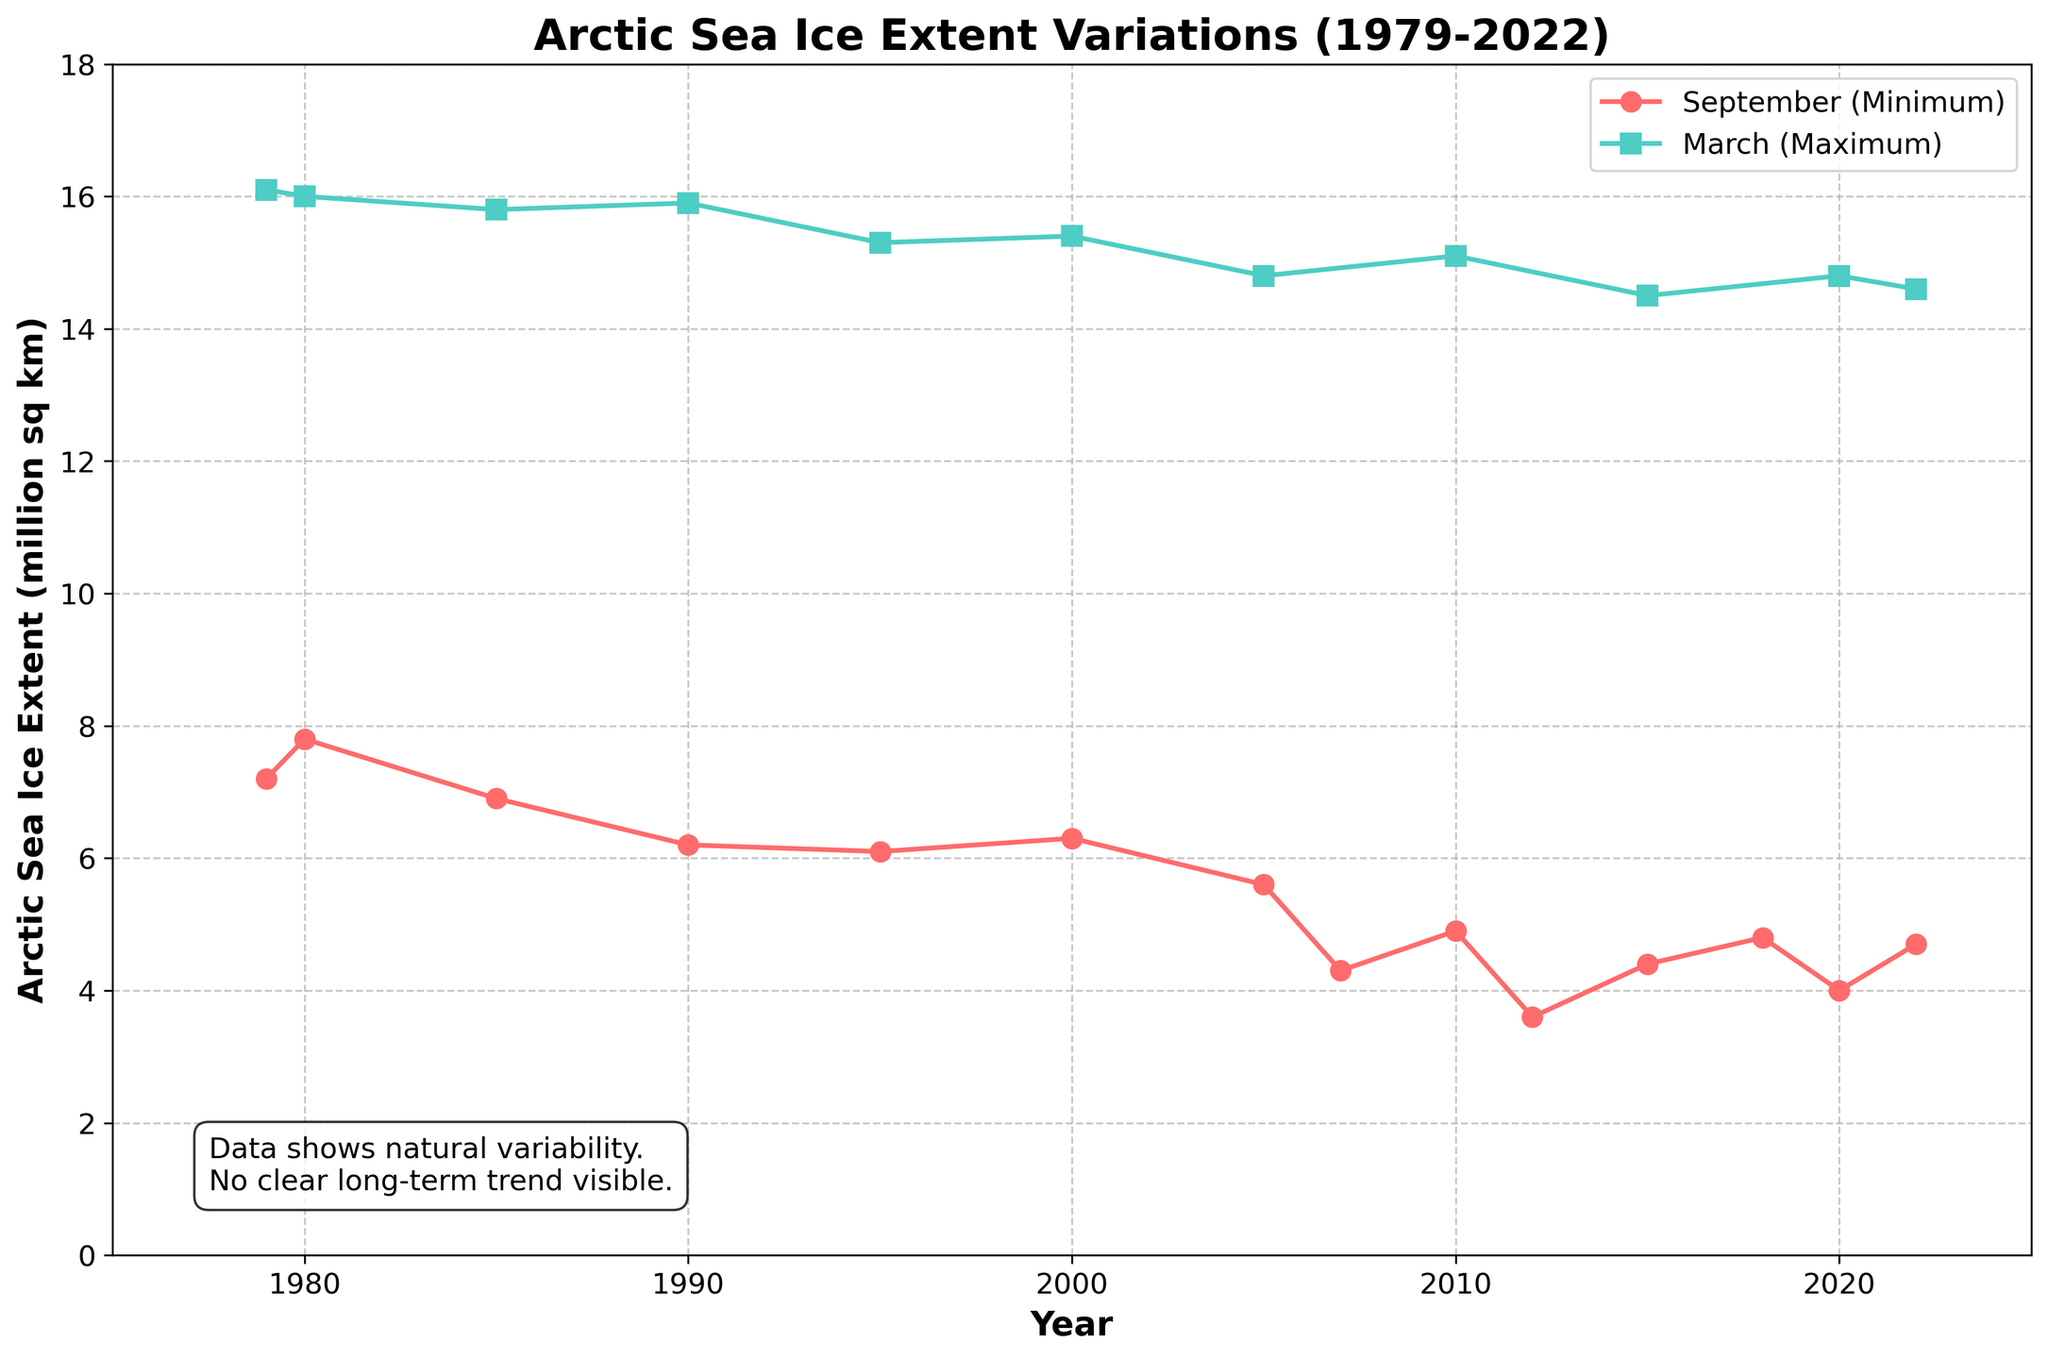What has been the overall trend in Arctic sea ice extent in September? The plot shows that the Arctic sea ice extent in September has generally declined from 1979 to 2022, starting around 7.2 million square kilometers in 1979 and reducing to about 4.7 million square kilometers in 2022.
Answer: Decline During which year did the Arctic sea ice extent reach the minimum value in September, and what was this value? By looking at the plot, the minimum value in September occurred in 2012 and the value was approximately 3.6 million square kilometers.
Answer: 2012, 3.6 million square kilometers How does the Arctic sea ice extent in March 2022 compare to that in March 1979? The Arctic sea ice extent in March 2022 is about 14.6 million square kilometers, while it was about 16.1 million square kilometers in March 1979, showing a decrease.
Answer: Decrease What is the difference in the Arctic sea ice extent between March and September of 2020? In 2020, the Arctic sea ice extent in March was about 14.8 million square kilometers, and in September, it was approximately 4.0 million square kilometers. The difference is 14.8 - 4.0 = 10.8 million square kilometers.
Answer: 10.8 million square kilometers Which year shows the largest difference between the March and September sea ice extent? By examining the plot, 2012 shows the largest difference, with March having around 15.1 million square kilometers and September around 3.6 million square kilometers. The difference is 15.1 - 3.6 = 11.5 million square kilometers.
Answer: 2012, 11.5 million square kilometers Between 1979 and 2022, how does the long-term trend in sea ice extent during March compare to that during September? The plot indicates that both March and September sea ice extents show a decreasing trend, but the decline in September is more pronounced.
Answer: Both decrease, September more How many years show a September sea ice extent of less than 5 million square kilometers? By analyzing the plot, September sea ice extent is less than 5 million square kilometers in the years 2007, 2010, 2012, 2015, 2020, and 2022. This counts to 6 years.
Answer: 6 years What is the average Arctic sea ice extent in March for the first and last three years on the plot? For the first three years (1979, 1980, 1985), the average March sea ice extent is (16.1 + 16.0 + 15.8)/3 = 15.97 million square kilometers. For the last three years (2020, 2022, 2015), the average is (14.8 + 14.6 + 14.5)/3 ≈ 14.63 million square kilometers.
Answer: First three: 15.97 million sq km; Last three: 14.63 million sq km 